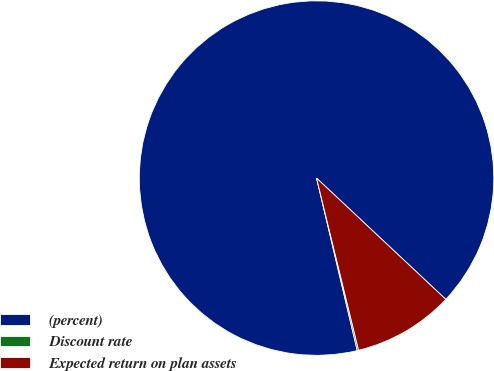Convert chart to OTSL. <chart><loc_0><loc_0><loc_500><loc_500><pie_chart><fcel>(percent)<fcel>Discount rate<fcel>Expected return on plan assets<nl><fcel>90.68%<fcel>0.13%<fcel>9.19%<nl></chart> 